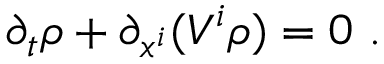<formula> <loc_0><loc_0><loc_500><loc_500>\partial _ { t } \rho + \partial _ { x ^ { i } } ( V ^ { i } \rho ) = 0 \ .</formula> 